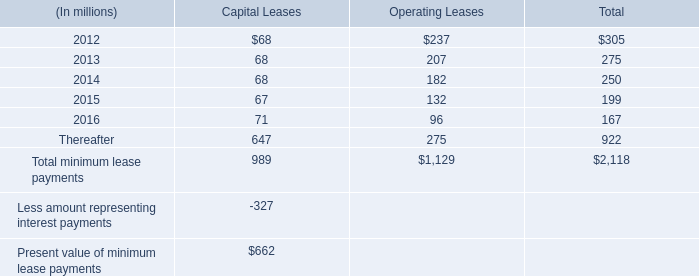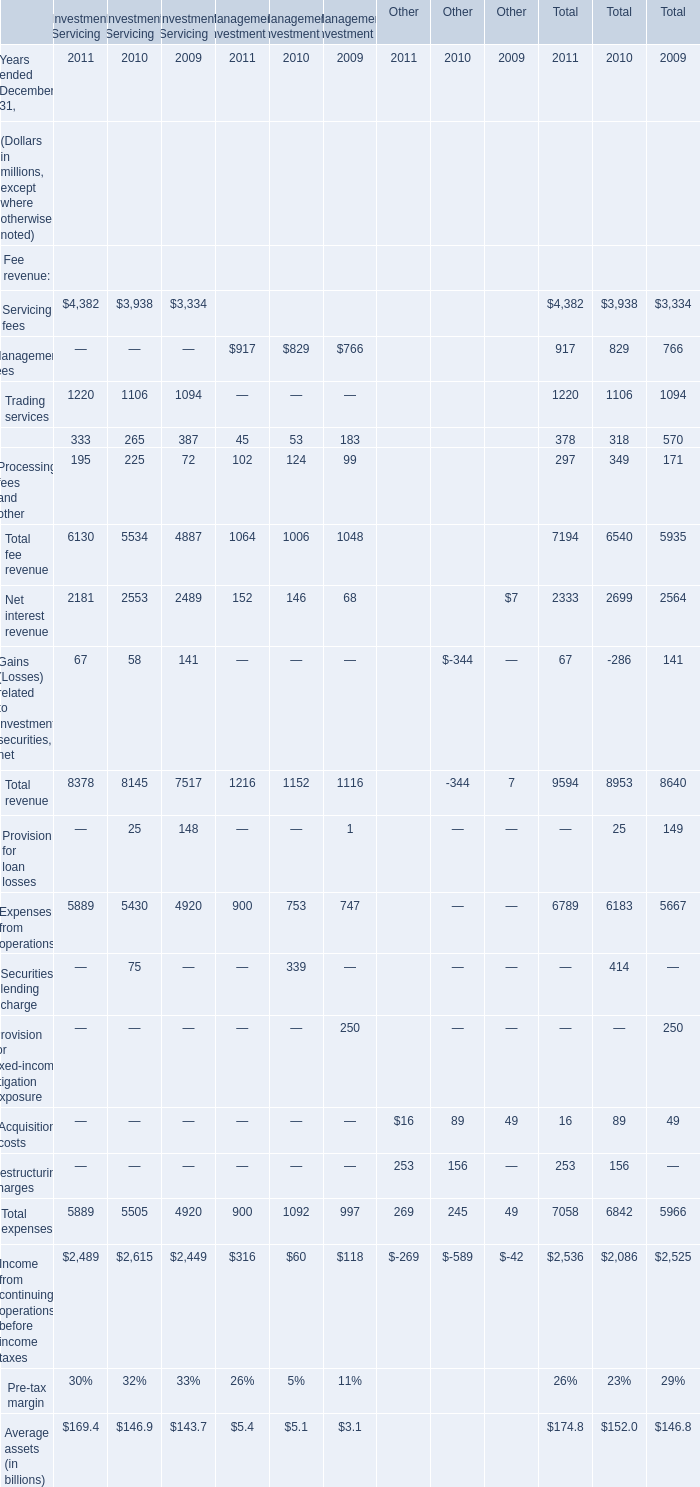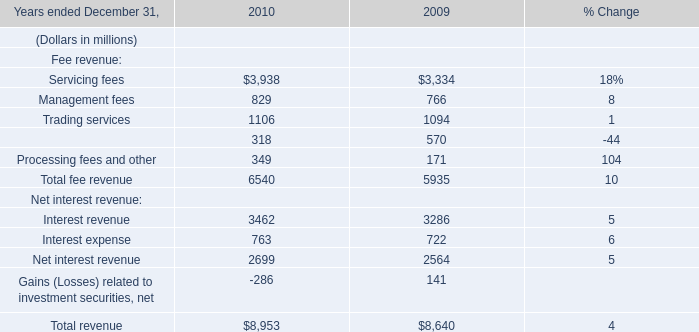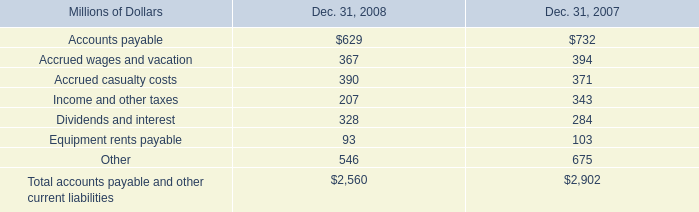What is the sum of the Securities finance in the years where Servicing fees is greater than 4000? (in million) 
Computations: (333 + 45)
Answer: 378.0. 